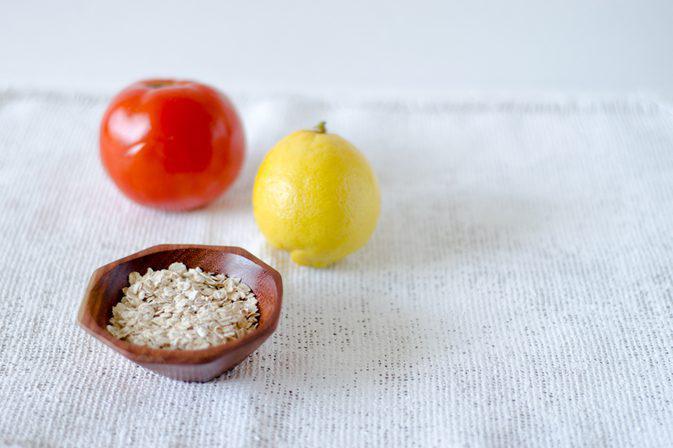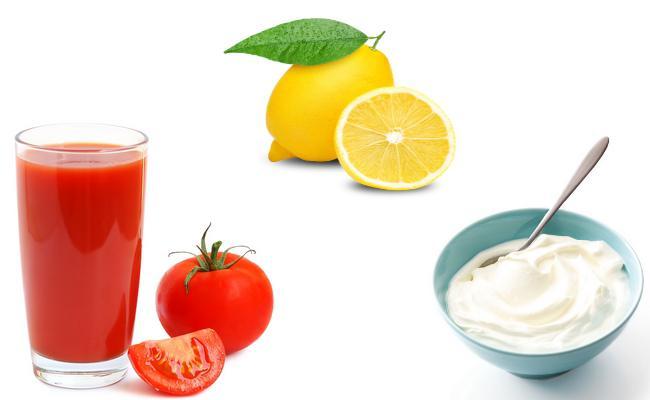The first image is the image on the left, the second image is the image on the right. For the images shown, is this caption "In the left image, there are the same number of lemons and tomatoes." true? Answer yes or no. Yes. The first image is the image on the left, the second image is the image on the right. Analyze the images presented: Is the assertion "An image without a beverage in a glass contains a whole tomato, whole lemons with green leaf, and a half lemon." valid? Answer yes or no. No. 